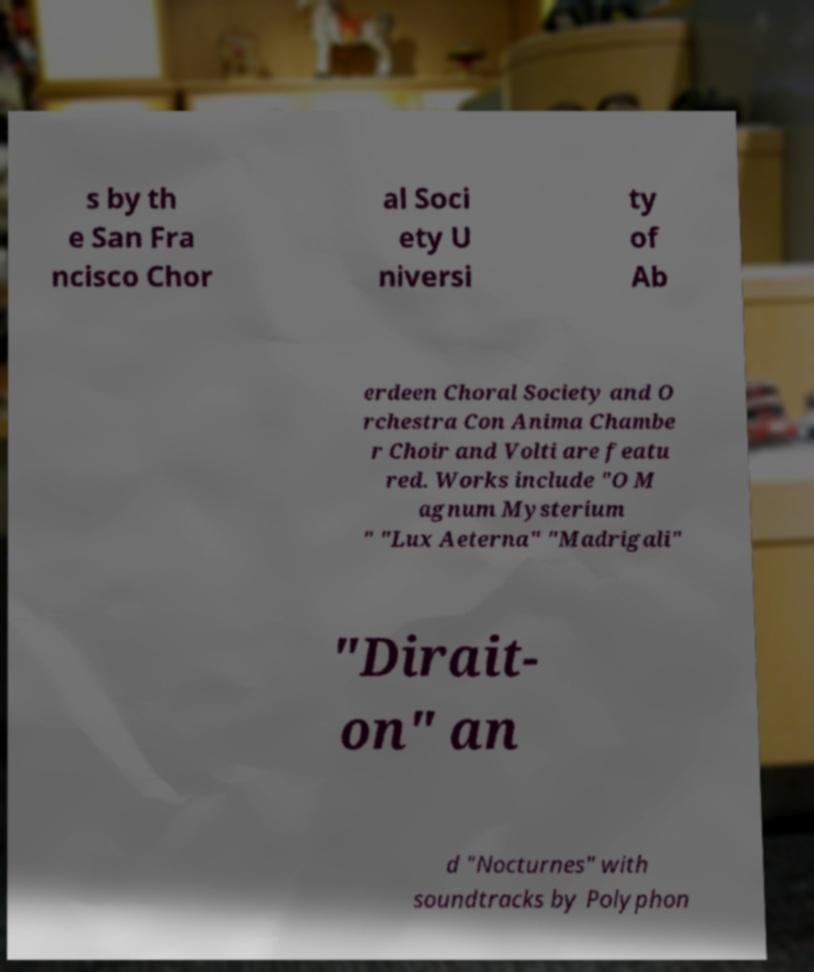Can you accurately transcribe the text from the provided image for me? s by th e San Fra ncisco Chor al Soci ety U niversi ty of Ab erdeen Choral Society and O rchestra Con Anima Chambe r Choir and Volti are featu red. Works include "O M agnum Mysterium " "Lux Aeterna" "Madrigali" "Dirait- on" an d "Nocturnes" with soundtracks by Polyphon 